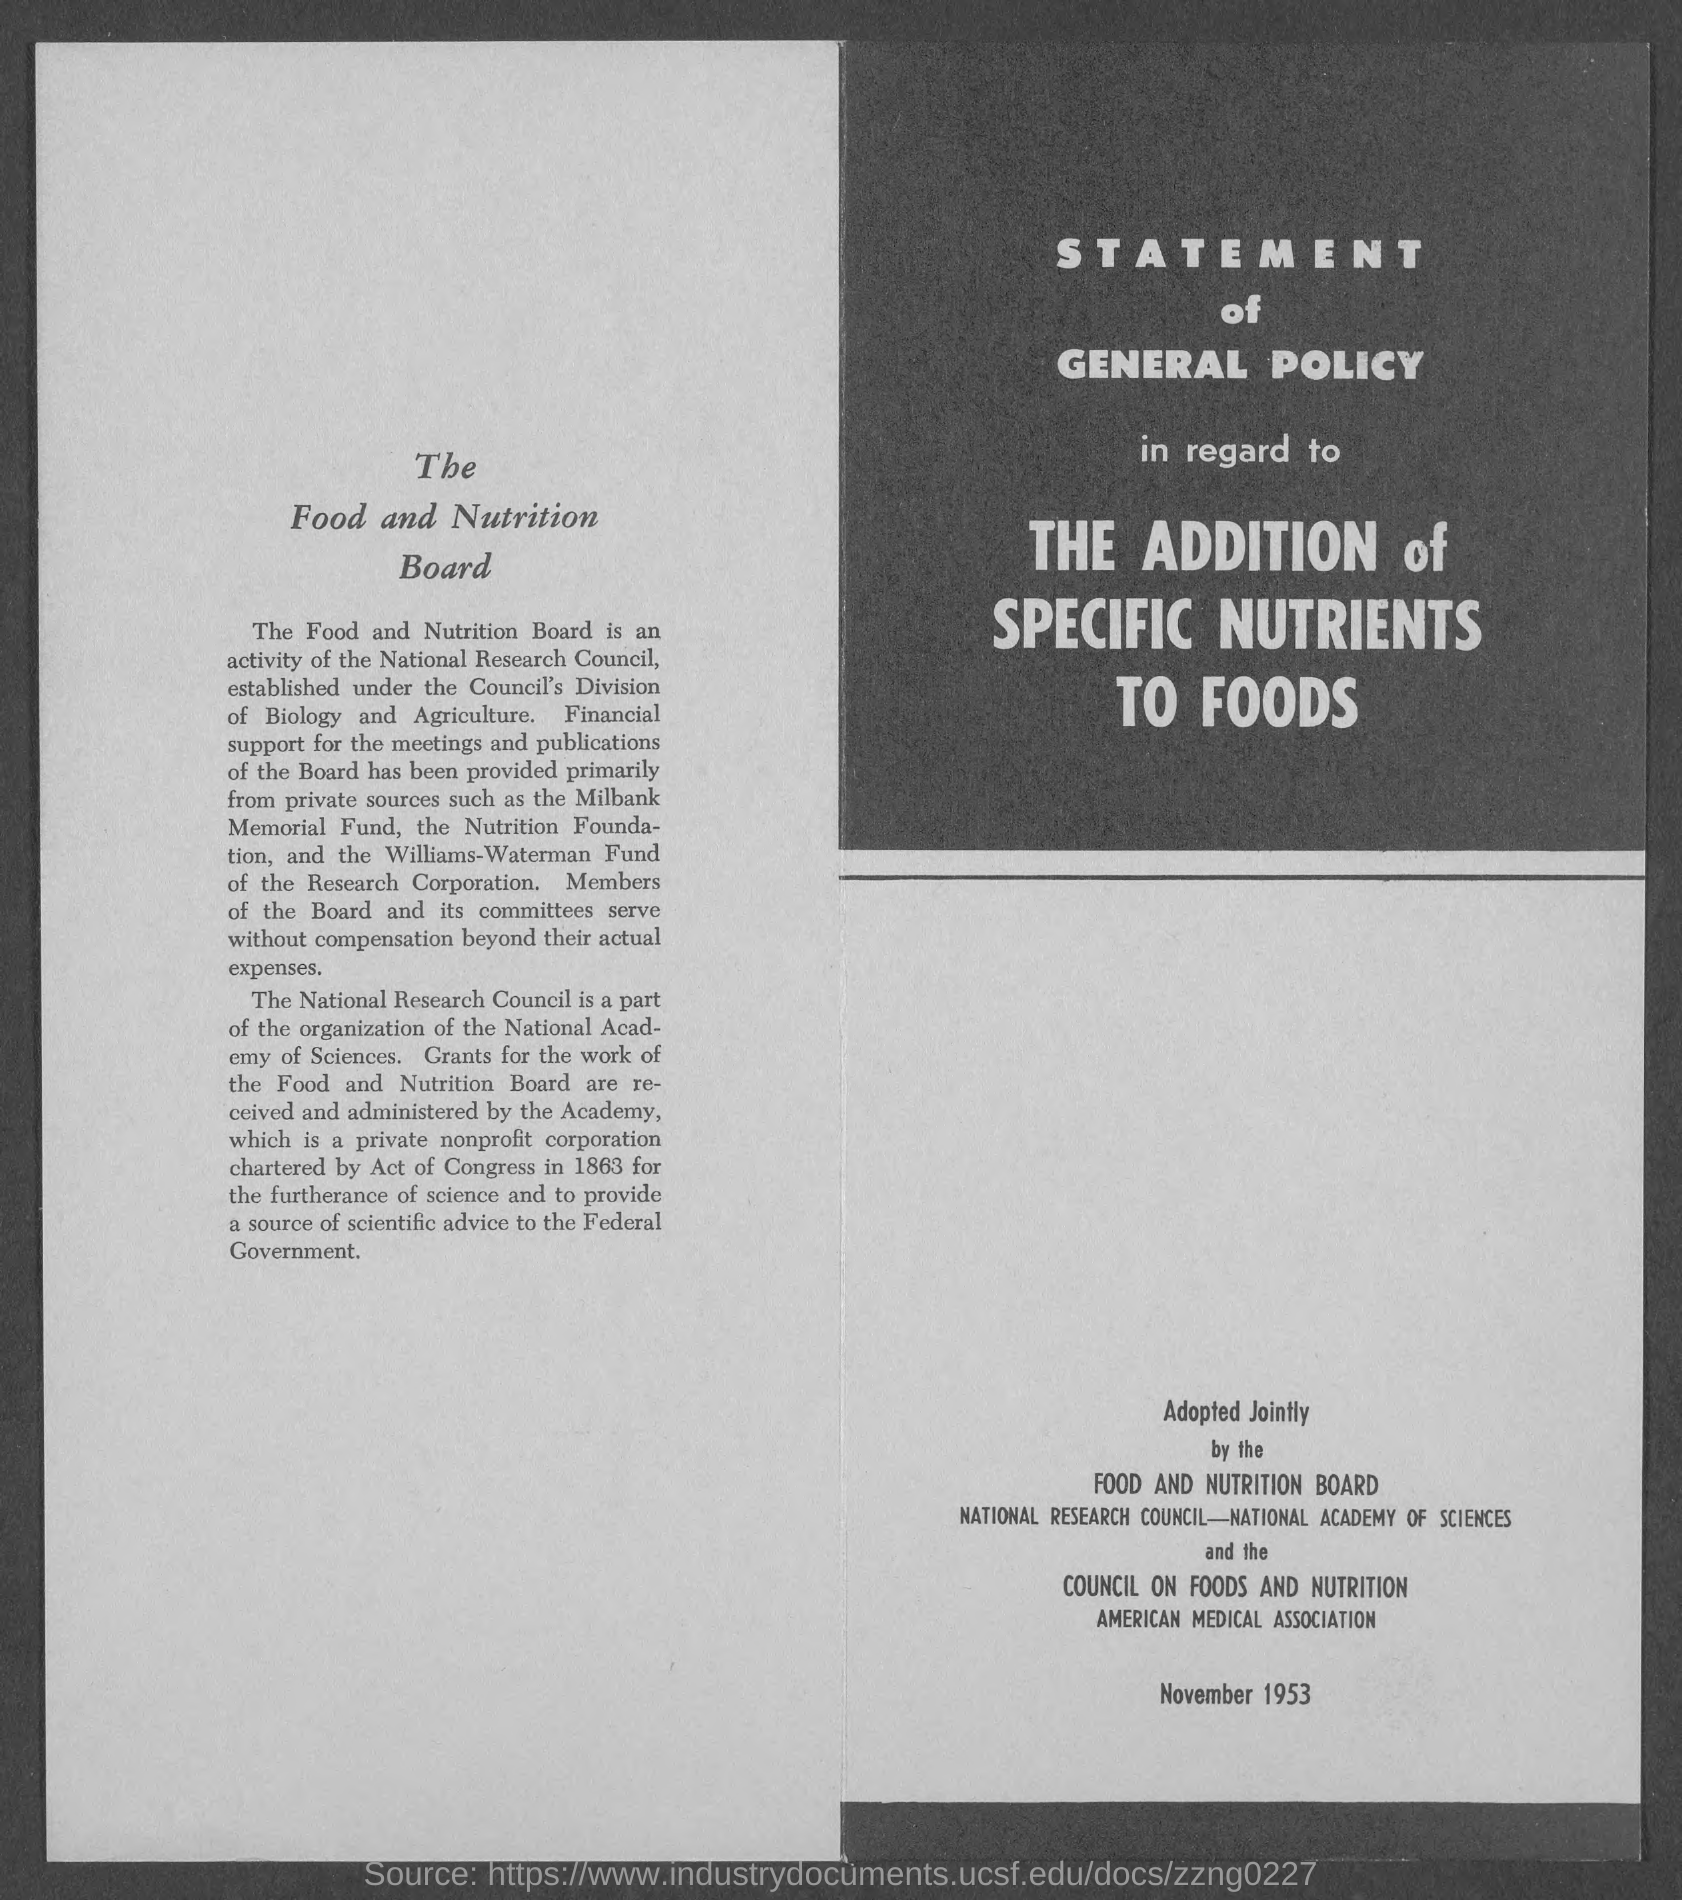Outline some significant characteristics in this image. The corporation that was chartered by an Act of Congress in 1863 is a private nonprofit organization. 